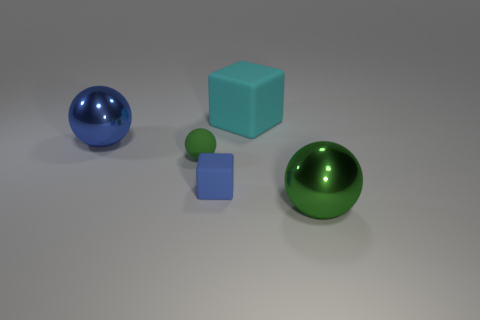Imagine these objects are part of a game. What could be the rules? If these objects were part of a game, the rules might revolve around their shapes and colors. For example, a player could earn points by matching objects with the same color or shape. The spheres could be 'rolling' pieces that move in straight lines until they hit an obstacle, while the cubes could be 'static' pieces that block pathways or change the direction of the spheres. The goal might be to position the objects in a specific pattern or to accumulate as many 'matches' as possible within a time limit. 